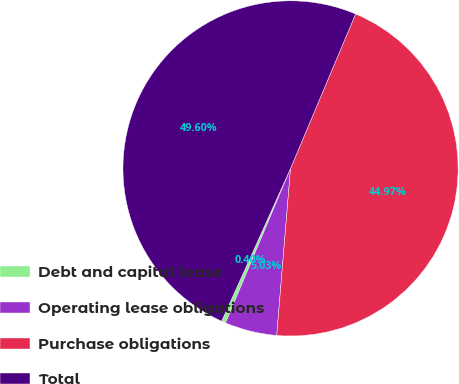<chart> <loc_0><loc_0><loc_500><loc_500><pie_chart><fcel>Debt and capital lease<fcel>Operating lease obligations<fcel>Purchase obligations<fcel>Total<nl><fcel>0.4%<fcel>5.03%<fcel>44.97%<fcel>49.6%<nl></chart> 